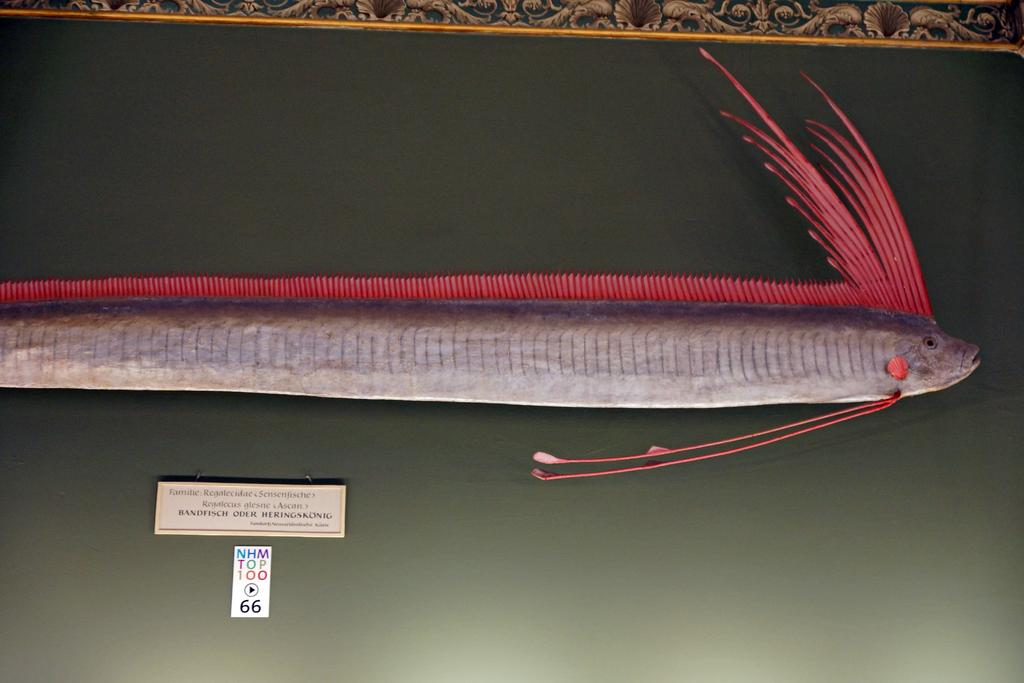What object is present in the image that typically holds a picture or artwork? There is a picture frame in the image. What type of artwork is displayed within the picture frame? The picture frame contains an art of fish. Is there any text present on the picture frame? Yes, there is text on the picture frame. What role does the brother play in the government, as depicted in the image? There is no mention of a brother or any government involvement in the image; it features a picture frame with an art of fish and text. 